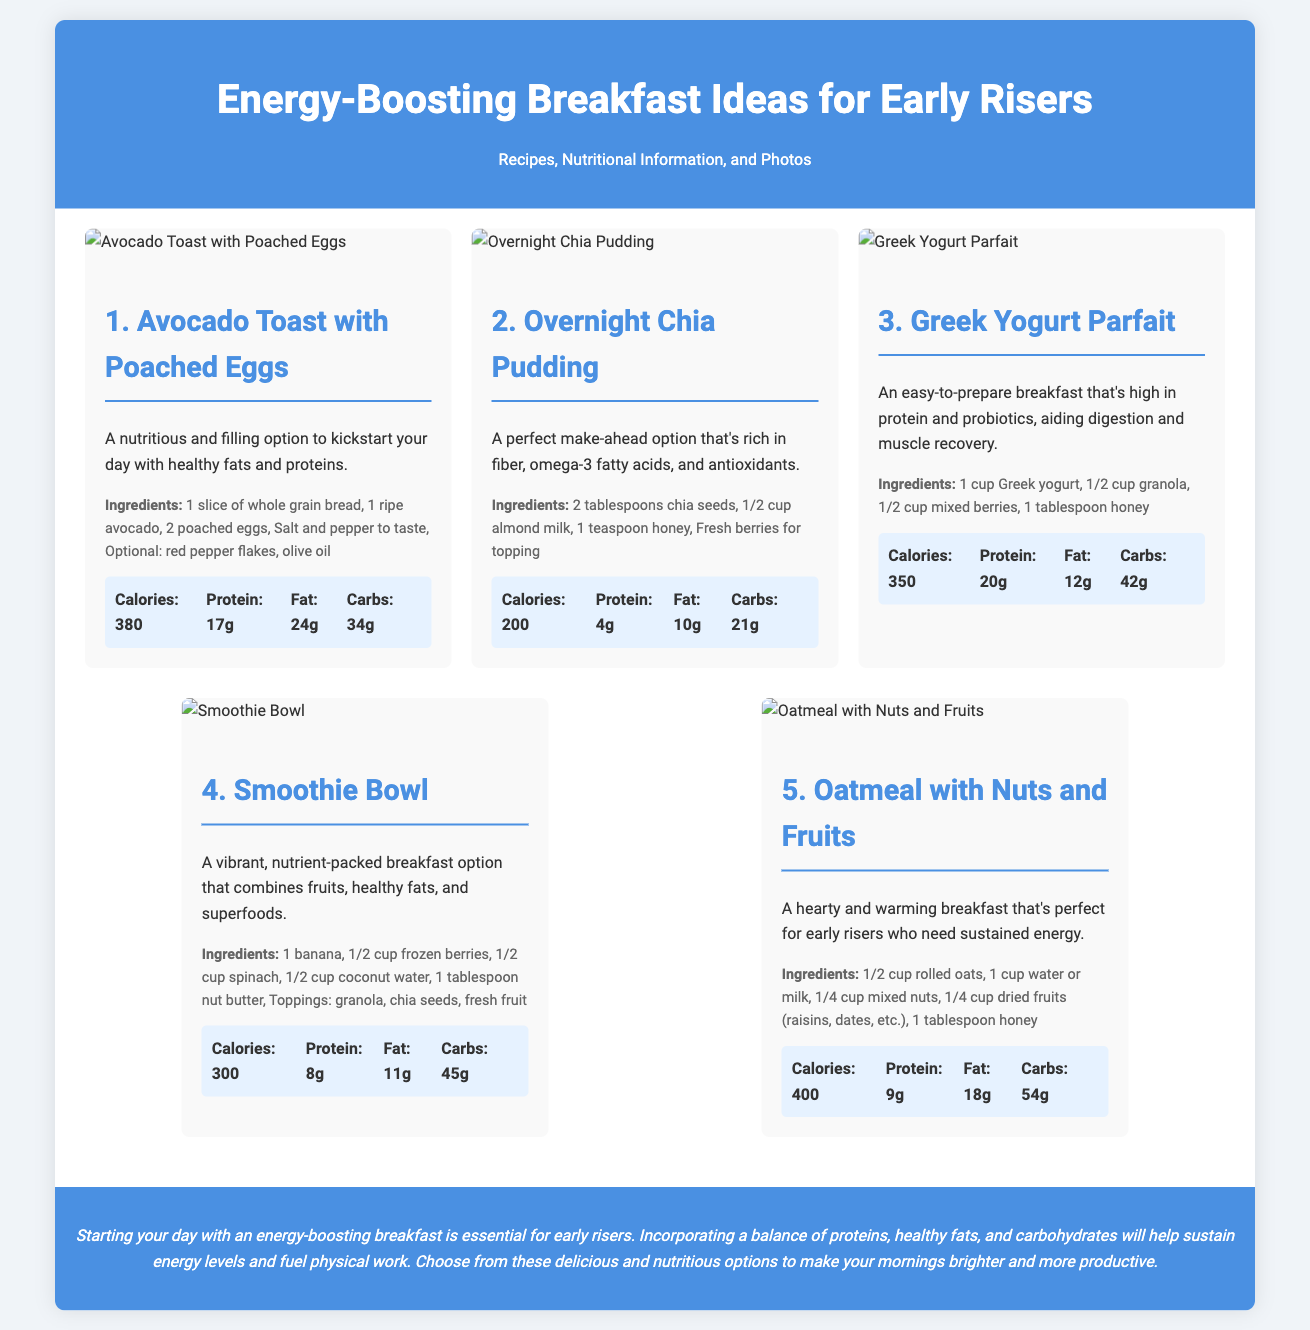What is the title of the presentation? The title of the presentation is prominently displayed at the top of the document.
Answer: Energy-Boosting Breakfast Ideas for Early Risers How many recipes are included in the presentation? The document lists a specific number of recipes in the content section.
Answer: Five What is the main ingredient in the "Avocado Toast with Poached Eggs"? The main ingredient is identified in the recipe description.
Answer: Avocado What is the calorie count for the "Overnight Chia Pudding"? The calorie count is specified in the nutritional information for this recipe.
Answer: 200 What type of breakfast is suggested for early risers? The document provides guidance for suitable options for a specific audience.
Answer: Energy-boosting What is a key nutritional benefit of the "Greek Yogurt Parfait"? This benefit is highlighted in the description of the recipe.
Answer: High in protein Which recipe contains spinach? The recipe includes specific ingredients that are listed under one of the options.
Answer: Smoothie Bowl What is the cooking method for the eggs in the "Avocado Toast"? The cooking method is explained in the recipe details.
Answer: Poached How does the presentation emphasize the importance of breakfast? The conclusion summarizes the main ideas about breakfast benefits.
Answer: Essential for energy levels 